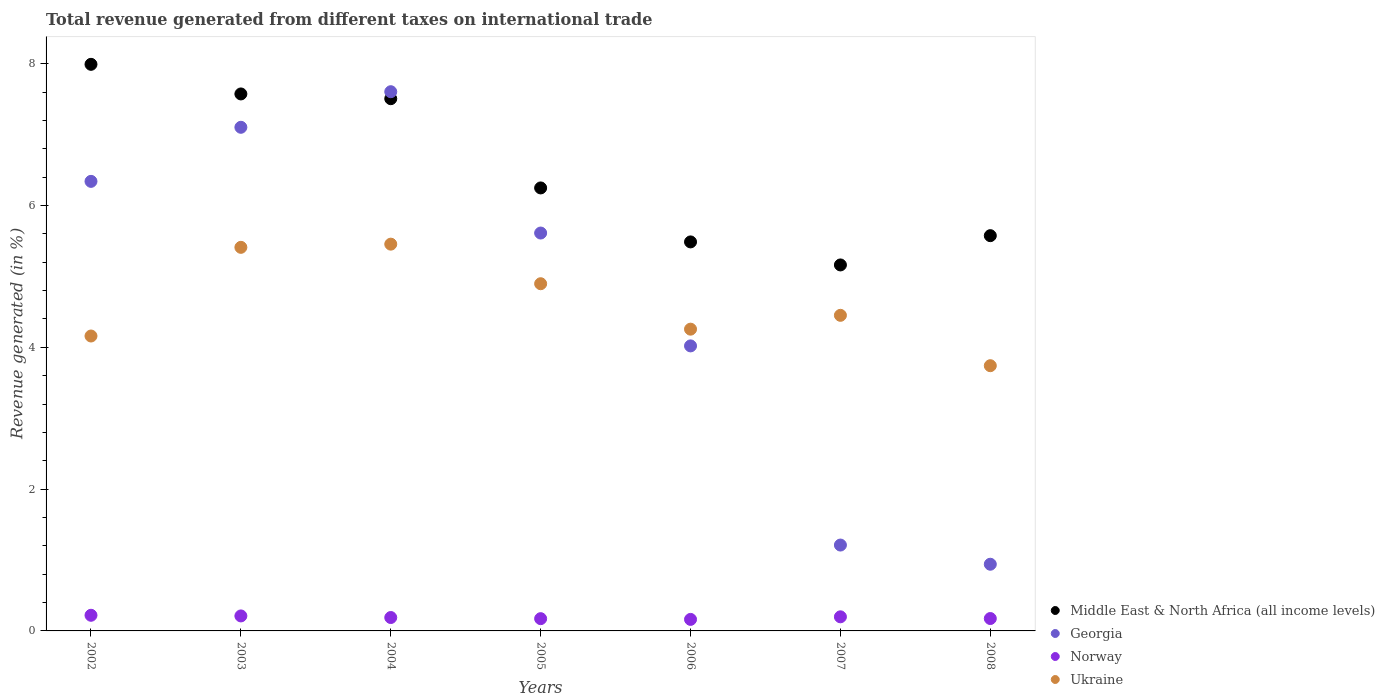Is the number of dotlines equal to the number of legend labels?
Make the answer very short. Yes. What is the total revenue generated in Georgia in 2003?
Give a very brief answer. 7.1. Across all years, what is the maximum total revenue generated in Georgia?
Ensure brevity in your answer.  7.61. Across all years, what is the minimum total revenue generated in Norway?
Keep it short and to the point. 0.16. What is the total total revenue generated in Ukraine in the graph?
Provide a short and direct response. 32.37. What is the difference between the total revenue generated in Norway in 2003 and that in 2005?
Your answer should be very brief. 0.04. What is the difference between the total revenue generated in Ukraine in 2005 and the total revenue generated in Norway in 2007?
Your answer should be very brief. 4.7. What is the average total revenue generated in Georgia per year?
Provide a succinct answer. 4.69. In the year 2005, what is the difference between the total revenue generated in Georgia and total revenue generated in Norway?
Keep it short and to the point. 5.44. What is the ratio of the total revenue generated in Norway in 2004 to that in 2006?
Your response must be concise. 1.16. Is the total revenue generated in Georgia in 2005 less than that in 2008?
Offer a terse response. No. What is the difference between the highest and the second highest total revenue generated in Middle East & North Africa (all income levels)?
Your answer should be very brief. 0.42. What is the difference between the highest and the lowest total revenue generated in Norway?
Your answer should be compact. 0.06. In how many years, is the total revenue generated in Georgia greater than the average total revenue generated in Georgia taken over all years?
Make the answer very short. 4. Is the sum of the total revenue generated in Norway in 2002 and 2005 greater than the maximum total revenue generated in Georgia across all years?
Keep it short and to the point. No. Is it the case that in every year, the sum of the total revenue generated in Middle East & North Africa (all income levels) and total revenue generated in Norway  is greater than the sum of total revenue generated in Georgia and total revenue generated in Ukraine?
Make the answer very short. Yes. Does the total revenue generated in Norway monotonically increase over the years?
Your answer should be compact. No. How many dotlines are there?
Offer a very short reply. 4. What is the difference between two consecutive major ticks on the Y-axis?
Your answer should be compact. 2. Are the values on the major ticks of Y-axis written in scientific E-notation?
Give a very brief answer. No. Does the graph contain any zero values?
Give a very brief answer. No. Does the graph contain grids?
Your answer should be compact. No. What is the title of the graph?
Make the answer very short. Total revenue generated from different taxes on international trade. Does "Lower middle income" appear as one of the legend labels in the graph?
Your answer should be very brief. No. What is the label or title of the Y-axis?
Make the answer very short. Revenue generated (in %). What is the Revenue generated (in %) of Middle East & North Africa (all income levels) in 2002?
Offer a very short reply. 7.99. What is the Revenue generated (in %) of Georgia in 2002?
Ensure brevity in your answer.  6.34. What is the Revenue generated (in %) in Norway in 2002?
Your answer should be compact. 0.22. What is the Revenue generated (in %) of Ukraine in 2002?
Ensure brevity in your answer.  4.16. What is the Revenue generated (in %) of Middle East & North Africa (all income levels) in 2003?
Your answer should be compact. 7.57. What is the Revenue generated (in %) in Georgia in 2003?
Offer a very short reply. 7.1. What is the Revenue generated (in %) of Norway in 2003?
Ensure brevity in your answer.  0.21. What is the Revenue generated (in %) in Ukraine in 2003?
Provide a short and direct response. 5.41. What is the Revenue generated (in %) of Middle East & North Africa (all income levels) in 2004?
Keep it short and to the point. 7.51. What is the Revenue generated (in %) of Georgia in 2004?
Keep it short and to the point. 7.61. What is the Revenue generated (in %) in Norway in 2004?
Your response must be concise. 0.19. What is the Revenue generated (in %) in Ukraine in 2004?
Provide a succinct answer. 5.46. What is the Revenue generated (in %) of Middle East & North Africa (all income levels) in 2005?
Give a very brief answer. 6.25. What is the Revenue generated (in %) in Georgia in 2005?
Offer a terse response. 5.61. What is the Revenue generated (in %) in Norway in 2005?
Offer a terse response. 0.17. What is the Revenue generated (in %) of Ukraine in 2005?
Offer a terse response. 4.9. What is the Revenue generated (in %) in Middle East & North Africa (all income levels) in 2006?
Ensure brevity in your answer.  5.49. What is the Revenue generated (in %) of Georgia in 2006?
Make the answer very short. 4.02. What is the Revenue generated (in %) of Norway in 2006?
Your answer should be compact. 0.16. What is the Revenue generated (in %) of Ukraine in 2006?
Provide a short and direct response. 4.26. What is the Revenue generated (in %) of Middle East & North Africa (all income levels) in 2007?
Your answer should be very brief. 5.16. What is the Revenue generated (in %) in Georgia in 2007?
Provide a succinct answer. 1.21. What is the Revenue generated (in %) of Norway in 2007?
Provide a succinct answer. 0.2. What is the Revenue generated (in %) in Ukraine in 2007?
Provide a succinct answer. 4.45. What is the Revenue generated (in %) of Middle East & North Africa (all income levels) in 2008?
Provide a short and direct response. 5.58. What is the Revenue generated (in %) of Georgia in 2008?
Your answer should be very brief. 0.94. What is the Revenue generated (in %) in Norway in 2008?
Ensure brevity in your answer.  0.17. What is the Revenue generated (in %) in Ukraine in 2008?
Offer a very short reply. 3.74. Across all years, what is the maximum Revenue generated (in %) in Middle East & North Africa (all income levels)?
Provide a short and direct response. 7.99. Across all years, what is the maximum Revenue generated (in %) of Georgia?
Offer a terse response. 7.61. Across all years, what is the maximum Revenue generated (in %) in Norway?
Make the answer very short. 0.22. Across all years, what is the maximum Revenue generated (in %) of Ukraine?
Give a very brief answer. 5.46. Across all years, what is the minimum Revenue generated (in %) of Middle East & North Africa (all income levels)?
Provide a succinct answer. 5.16. Across all years, what is the minimum Revenue generated (in %) of Georgia?
Give a very brief answer. 0.94. Across all years, what is the minimum Revenue generated (in %) in Norway?
Make the answer very short. 0.16. Across all years, what is the minimum Revenue generated (in %) of Ukraine?
Keep it short and to the point. 3.74. What is the total Revenue generated (in %) of Middle East & North Africa (all income levels) in the graph?
Your answer should be compact. 45.55. What is the total Revenue generated (in %) in Georgia in the graph?
Your answer should be very brief. 32.84. What is the total Revenue generated (in %) in Norway in the graph?
Offer a very short reply. 1.33. What is the total Revenue generated (in %) in Ukraine in the graph?
Provide a short and direct response. 32.37. What is the difference between the Revenue generated (in %) of Middle East & North Africa (all income levels) in 2002 and that in 2003?
Provide a short and direct response. 0.42. What is the difference between the Revenue generated (in %) of Georgia in 2002 and that in 2003?
Provide a short and direct response. -0.76. What is the difference between the Revenue generated (in %) in Norway in 2002 and that in 2003?
Make the answer very short. 0.01. What is the difference between the Revenue generated (in %) of Ukraine in 2002 and that in 2003?
Provide a succinct answer. -1.25. What is the difference between the Revenue generated (in %) in Middle East & North Africa (all income levels) in 2002 and that in 2004?
Your response must be concise. 0.48. What is the difference between the Revenue generated (in %) in Georgia in 2002 and that in 2004?
Make the answer very short. -1.26. What is the difference between the Revenue generated (in %) in Norway in 2002 and that in 2004?
Provide a succinct answer. 0.03. What is the difference between the Revenue generated (in %) in Ukraine in 2002 and that in 2004?
Give a very brief answer. -1.3. What is the difference between the Revenue generated (in %) in Middle East & North Africa (all income levels) in 2002 and that in 2005?
Your answer should be very brief. 1.74. What is the difference between the Revenue generated (in %) in Georgia in 2002 and that in 2005?
Keep it short and to the point. 0.73. What is the difference between the Revenue generated (in %) of Norway in 2002 and that in 2005?
Make the answer very short. 0.05. What is the difference between the Revenue generated (in %) of Ukraine in 2002 and that in 2005?
Ensure brevity in your answer.  -0.74. What is the difference between the Revenue generated (in %) of Middle East & North Africa (all income levels) in 2002 and that in 2006?
Offer a terse response. 2.5. What is the difference between the Revenue generated (in %) in Georgia in 2002 and that in 2006?
Make the answer very short. 2.32. What is the difference between the Revenue generated (in %) of Norway in 2002 and that in 2006?
Keep it short and to the point. 0.06. What is the difference between the Revenue generated (in %) in Ukraine in 2002 and that in 2006?
Give a very brief answer. -0.1. What is the difference between the Revenue generated (in %) of Middle East & North Africa (all income levels) in 2002 and that in 2007?
Your answer should be compact. 2.83. What is the difference between the Revenue generated (in %) of Georgia in 2002 and that in 2007?
Make the answer very short. 5.13. What is the difference between the Revenue generated (in %) of Norway in 2002 and that in 2007?
Your answer should be very brief. 0.02. What is the difference between the Revenue generated (in %) in Ukraine in 2002 and that in 2007?
Offer a very short reply. -0.29. What is the difference between the Revenue generated (in %) in Middle East & North Africa (all income levels) in 2002 and that in 2008?
Provide a short and direct response. 2.42. What is the difference between the Revenue generated (in %) of Georgia in 2002 and that in 2008?
Ensure brevity in your answer.  5.4. What is the difference between the Revenue generated (in %) in Norway in 2002 and that in 2008?
Provide a succinct answer. 0.05. What is the difference between the Revenue generated (in %) of Ukraine in 2002 and that in 2008?
Your answer should be compact. 0.42. What is the difference between the Revenue generated (in %) in Middle East & North Africa (all income levels) in 2003 and that in 2004?
Ensure brevity in your answer.  0.07. What is the difference between the Revenue generated (in %) of Georgia in 2003 and that in 2004?
Your response must be concise. -0.5. What is the difference between the Revenue generated (in %) of Norway in 2003 and that in 2004?
Offer a terse response. 0.02. What is the difference between the Revenue generated (in %) in Ukraine in 2003 and that in 2004?
Offer a terse response. -0.04. What is the difference between the Revenue generated (in %) in Middle East & North Africa (all income levels) in 2003 and that in 2005?
Keep it short and to the point. 1.33. What is the difference between the Revenue generated (in %) of Georgia in 2003 and that in 2005?
Provide a short and direct response. 1.49. What is the difference between the Revenue generated (in %) of Norway in 2003 and that in 2005?
Your answer should be very brief. 0.04. What is the difference between the Revenue generated (in %) of Ukraine in 2003 and that in 2005?
Offer a very short reply. 0.51. What is the difference between the Revenue generated (in %) in Middle East & North Africa (all income levels) in 2003 and that in 2006?
Make the answer very short. 2.09. What is the difference between the Revenue generated (in %) of Georgia in 2003 and that in 2006?
Offer a very short reply. 3.08. What is the difference between the Revenue generated (in %) in Norway in 2003 and that in 2006?
Offer a terse response. 0.05. What is the difference between the Revenue generated (in %) in Ukraine in 2003 and that in 2006?
Your answer should be very brief. 1.15. What is the difference between the Revenue generated (in %) in Middle East & North Africa (all income levels) in 2003 and that in 2007?
Your answer should be very brief. 2.41. What is the difference between the Revenue generated (in %) in Georgia in 2003 and that in 2007?
Give a very brief answer. 5.89. What is the difference between the Revenue generated (in %) in Norway in 2003 and that in 2007?
Offer a terse response. 0.01. What is the difference between the Revenue generated (in %) of Middle East & North Africa (all income levels) in 2003 and that in 2008?
Offer a terse response. 2. What is the difference between the Revenue generated (in %) of Georgia in 2003 and that in 2008?
Offer a very short reply. 6.16. What is the difference between the Revenue generated (in %) in Norway in 2003 and that in 2008?
Your answer should be very brief. 0.04. What is the difference between the Revenue generated (in %) in Ukraine in 2003 and that in 2008?
Offer a very short reply. 1.67. What is the difference between the Revenue generated (in %) in Middle East & North Africa (all income levels) in 2004 and that in 2005?
Your answer should be very brief. 1.26. What is the difference between the Revenue generated (in %) in Georgia in 2004 and that in 2005?
Provide a succinct answer. 1.99. What is the difference between the Revenue generated (in %) of Norway in 2004 and that in 2005?
Provide a succinct answer. 0.02. What is the difference between the Revenue generated (in %) in Ukraine in 2004 and that in 2005?
Offer a terse response. 0.56. What is the difference between the Revenue generated (in %) in Middle East & North Africa (all income levels) in 2004 and that in 2006?
Your response must be concise. 2.02. What is the difference between the Revenue generated (in %) in Georgia in 2004 and that in 2006?
Offer a very short reply. 3.59. What is the difference between the Revenue generated (in %) in Norway in 2004 and that in 2006?
Make the answer very short. 0.03. What is the difference between the Revenue generated (in %) of Ukraine in 2004 and that in 2006?
Keep it short and to the point. 1.2. What is the difference between the Revenue generated (in %) in Middle East & North Africa (all income levels) in 2004 and that in 2007?
Offer a terse response. 2.34. What is the difference between the Revenue generated (in %) of Georgia in 2004 and that in 2007?
Provide a succinct answer. 6.39. What is the difference between the Revenue generated (in %) of Norway in 2004 and that in 2007?
Make the answer very short. -0.01. What is the difference between the Revenue generated (in %) in Ukraine in 2004 and that in 2007?
Your response must be concise. 1. What is the difference between the Revenue generated (in %) in Middle East & North Africa (all income levels) in 2004 and that in 2008?
Your answer should be compact. 1.93. What is the difference between the Revenue generated (in %) of Georgia in 2004 and that in 2008?
Your answer should be compact. 6.67. What is the difference between the Revenue generated (in %) in Norway in 2004 and that in 2008?
Keep it short and to the point. 0.01. What is the difference between the Revenue generated (in %) of Ukraine in 2004 and that in 2008?
Make the answer very short. 1.71. What is the difference between the Revenue generated (in %) of Middle East & North Africa (all income levels) in 2005 and that in 2006?
Your answer should be compact. 0.76. What is the difference between the Revenue generated (in %) of Georgia in 2005 and that in 2006?
Offer a very short reply. 1.59. What is the difference between the Revenue generated (in %) in Norway in 2005 and that in 2006?
Provide a succinct answer. 0.01. What is the difference between the Revenue generated (in %) in Ukraine in 2005 and that in 2006?
Provide a short and direct response. 0.64. What is the difference between the Revenue generated (in %) of Middle East & North Africa (all income levels) in 2005 and that in 2007?
Keep it short and to the point. 1.09. What is the difference between the Revenue generated (in %) in Georgia in 2005 and that in 2007?
Your answer should be very brief. 4.4. What is the difference between the Revenue generated (in %) in Norway in 2005 and that in 2007?
Provide a short and direct response. -0.03. What is the difference between the Revenue generated (in %) of Ukraine in 2005 and that in 2007?
Offer a terse response. 0.45. What is the difference between the Revenue generated (in %) of Middle East & North Africa (all income levels) in 2005 and that in 2008?
Keep it short and to the point. 0.67. What is the difference between the Revenue generated (in %) of Georgia in 2005 and that in 2008?
Offer a terse response. 4.67. What is the difference between the Revenue generated (in %) of Norway in 2005 and that in 2008?
Ensure brevity in your answer.  -0. What is the difference between the Revenue generated (in %) of Ukraine in 2005 and that in 2008?
Offer a very short reply. 1.16. What is the difference between the Revenue generated (in %) in Middle East & North Africa (all income levels) in 2006 and that in 2007?
Make the answer very short. 0.32. What is the difference between the Revenue generated (in %) of Georgia in 2006 and that in 2007?
Your response must be concise. 2.81. What is the difference between the Revenue generated (in %) in Norway in 2006 and that in 2007?
Your answer should be very brief. -0.04. What is the difference between the Revenue generated (in %) of Ukraine in 2006 and that in 2007?
Ensure brevity in your answer.  -0.2. What is the difference between the Revenue generated (in %) of Middle East & North Africa (all income levels) in 2006 and that in 2008?
Offer a very short reply. -0.09. What is the difference between the Revenue generated (in %) in Georgia in 2006 and that in 2008?
Offer a very short reply. 3.08. What is the difference between the Revenue generated (in %) of Norway in 2006 and that in 2008?
Your response must be concise. -0.01. What is the difference between the Revenue generated (in %) of Ukraine in 2006 and that in 2008?
Provide a succinct answer. 0.52. What is the difference between the Revenue generated (in %) of Middle East & North Africa (all income levels) in 2007 and that in 2008?
Provide a succinct answer. -0.41. What is the difference between the Revenue generated (in %) of Georgia in 2007 and that in 2008?
Offer a very short reply. 0.27. What is the difference between the Revenue generated (in %) in Norway in 2007 and that in 2008?
Make the answer very short. 0.02. What is the difference between the Revenue generated (in %) in Ukraine in 2007 and that in 2008?
Give a very brief answer. 0.71. What is the difference between the Revenue generated (in %) of Middle East & North Africa (all income levels) in 2002 and the Revenue generated (in %) of Georgia in 2003?
Provide a short and direct response. 0.89. What is the difference between the Revenue generated (in %) in Middle East & North Africa (all income levels) in 2002 and the Revenue generated (in %) in Norway in 2003?
Ensure brevity in your answer.  7.78. What is the difference between the Revenue generated (in %) in Middle East & North Africa (all income levels) in 2002 and the Revenue generated (in %) in Ukraine in 2003?
Your answer should be very brief. 2.58. What is the difference between the Revenue generated (in %) of Georgia in 2002 and the Revenue generated (in %) of Norway in 2003?
Make the answer very short. 6.13. What is the difference between the Revenue generated (in %) in Georgia in 2002 and the Revenue generated (in %) in Ukraine in 2003?
Offer a terse response. 0.93. What is the difference between the Revenue generated (in %) in Norway in 2002 and the Revenue generated (in %) in Ukraine in 2003?
Make the answer very short. -5.19. What is the difference between the Revenue generated (in %) of Middle East & North Africa (all income levels) in 2002 and the Revenue generated (in %) of Georgia in 2004?
Your answer should be compact. 0.39. What is the difference between the Revenue generated (in %) of Middle East & North Africa (all income levels) in 2002 and the Revenue generated (in %) of Norway in 2004?
Give a very brief answer. 7.8. What is the difference between the Revenue generated (in %) in Middle East & North Africa (all income levels) in 2002 and the Revenue generated (in %) in Ukraine in 2004?
Provide a succinct answer. 2.54. What is the difference between the Revenue generated (in %) in Georgia in 2002 and the Revenue generated (in %) in Norway in 2004?
Make the answer very short. 6.15. What is the difference between the Revenue generated (in %) of Georgia in 2002 and the Revenue generated (in %) of Ukraine in 2004?
Offer a terse response. 0.89. What is the difference between the Revenue generated (in %) of Norway in 2002 and the Revenue generated (in %) of Ukraine in 2004?
Provide a short and direct response. -5.23. What is the difference between the Revenue generated (in %) in Middle East & North Africa (all income levels) in 2002 and the Revenue generated (in %) in Georgia in 2005?
Ensure brevity in your answer.  2.38. What is the difference between the Revenue generated (in %) of Middle East & North Africa (all income levels) in 2002 and the Revenue generated (in %) of Norway in 2005?
Ensure brevity in your answer.  7.82. What is the difference between the Revenue generated (in %) in Middle East & North Africa (all income levels) in 2002 and the Revenue generated (in %) in Ukraine in 2005?
Give a very brief answer. 3.09. What is the difference between the Revenue generated (in %) of Georgia in 2002 and the Revenue generated (in %) of Norway in 2005?
Offer a very short reply. 6.17. What is the difference between the Revenue generated (in %) of Georgia in 2002 and the Revenue generated (in %) of Ukraine in 2005?
Keep it short and to the point. 1.44. What is the difference between the Revenue generated (in %) of Norway in 2002 and the Revenue generated (in %) of Ukraine in 2005?
Make the answer very short. -4.68. What is the difference between the Revenue generated (in %) of Middle East & North Africa (all income levels) in 2002 and the Revenue generated (in %) of Georgia in 2006?
Your response must be concise. 3.97. What is the difference between the Revenue generated (in %) in Middle East & North Africa (all income levels) in 2002 and the Revenue generated (in %) in Norway in 2006?
Your answer should be compact. 7.83. What is the difference between the Revenue generated (in %) of Middle East & North Africa (all income levels) in 2002 and the Revenue generated (in %) of Ukraine in 2006?
Your answer should be compact. 3.74. What is the difference between the Revenue generated (in %) of Georgia in 2002 and the Revenue generated (in %) of Norway in 2006?
Provide a succinct answer. 6.18. What is the difference between the Revenue generated (in %) of Georgia in 2002 and the Revenue generated (in %) of Ukraine in 2006?
Your response must be concise. 2.08. What is the difference between the Revenue generated (in %) of Norway in 2002 and the Revenue generated (in %) of Ukraine in 2006?
Make the answer very short. -4.04. What is the difference between the Revenue generated (in %) of Middle East & North Africa (all income levels) in 2002 and the Revenue generated (in %) of Georgia in 2007?
Offer a terse response. 6.78. What is the difference between the Revenue generated (in %) of Middle East & North Africa (all income levels) in 2002 and the Revenue generated (in %) of Norway in 2007?
Ensure brevity in your answer.  7.79. What is the difference between the Revenue generated (in %) in Middle East & North Africa (all income levels) in 2002 and the Revenue generated (in %) in Ukraine in 2007?
Ensure brevity in your answer.  3.54. What is the difference between the Revenue generated (in %) in Georgia in 2002 and the Revenue generated (in %) in Norway in 2007?
Keep it short and to the point. 6.14. What is the difference between the Revenue generated (in %) in Georgia in 2002 and the Revenue generated (in %) in Ukraine in 2007?
Your response must be concise. 1.89. What is the difference between the Revenue generated (in %) in Norway in 2002 and the Revenue generated (in %) in Ukraine in 2007?
Provide a short and direct response. -4.23. What is the difference between the Revenue generated (in %) of Middle East & North Africa (all income levels) in 2002 and the Revenue generated (in %) of Georgia in 2008?
Offer a very short reply. 7.05. What is the difference between the Revenue generated (in %) of Middle East & North Africa (all income levels) in 2002 and the Revenue generated (in %) of Norway in 2008?
Your answer should be very brief. 7.82. What is the difference between the Revenue generated (in %) in Middle East & North Africa (all income levels) in 2002 and the Revenue generated (in %) in Ukraine in 2008?
Offer a terse response. 4.25. What is the difference between the Revenue generated (in %) of Georgia in 2002 and the Revenue generated (in %) of Norway in 2008?
Keep it short and to the point. 6.17. What is the difference between the Revenue generated (in %) in Georgia in 2002 and the Revenue generated (in %) in Ukraine in 2008?
Your answer should be very brief. 2.6. What is the difference between the Revenue generated (in %) in Norway in 2002 and the Revenue generated (in %) in Ukraine in 2008?
Give a very brief answer. -3.52. What is the difference between the Revenue generated (in %) of Middle East & North Africa (all income levels) in 2003 and the Revenue generated (in %) of Georgia in 2004?
Offer a very short reply. -0.03. What is the difference between the Revenue generated (in %) of Middle East & North Africa (all income levels) in 2003 and the Revenue generated (in %) of Norway in 2004?
Your answer should be very brief. 7.39. What is the difference between the Revenue generated (in %) in Middle East & North Africa (all income levels) in 2003 and the Revenue generated (in %) in Ukraine in 2004?
Provide a short and direct response. 2.12. What is the difference between the Revenue generated (in %) in Georgia in 2003 and the Revenue generated (in %) in Norway in 2004?
Your answer should be compact. 6.91. What is the difference between the Revenue generated (in %) of Georgia in 2003 and the Revenue generated (in %) of Ukraine in 2004?
Ensure brevity in your answer.  1.65. What is the difference between the Revenue generated (in %) of Norway in 2003 and the Revenue generated (in %) of Ukraine in 2004?
Give a very brief answer. -5.24. What is the difference between the Revenue generated (in %) in Middle East & North Africa (all income levels) in 2003 and the Revenue generated (in %) in Georgia in 2005?
Offer a very short reply. 1.96. What is the difference between the Revenue generated (in %) of Middle East & North Africa (all income levels) in 2003 and the Revenue generated (in %) of Norway in 2005?
Offer a terse response. 7.4. What is the difference between the Revenue generated (in %) of Middle East & North Africa (all income levels) in 2003 and the Revenue generated (in %) of Ukraine in 2005?
Give a very brief answer. 2.68. What is the difference between the Revenue generated (in %) in Georgia in 2003 and the Revenue generated (in %) in Norway in 2005?
Make the answer very short. 6.93. What is the difference between the Revenue generated (in %) in Georgia in 2003 and the Revenue generated (in %) in Ukraine in 2005?
Provide a succinct answer. 2.21. What is the difference between the Revenue generated (in %) in Norway in 2003 and the Revenue generated (in %) in Ukraine in 2005?
Offer a terse response. -4.69. What is the difference between the Revenue generated (in %) of Middle East & North Africa (all income levels) in 2003 and the Revenue generated (in %) of Georgia in 2006?
Make the answer very short. 3.55. What is the difference between the Revenue generated (in %) in Middle East & North Africa (all income levels) in 2003 and the Revenue generated (in %) in Norway in 2006?
Provide a succinct answer. 7.41. What is the difference between the Revenue generated (in %) in Middle East & North Africa (all income levels) in 2003 and the Revenue generated (in %) in Ukraine in 2006?
Offer a terse response. 3.32. What is the difference between the Revenue generated (in %) of Georgia in 2003 and the Revenue generated (in %) of Norway in 2006?
Your answer should be compact. 6.94. What is the difference between the Revenue generated (in %) in Georgia in 2003 and the Revenue generated (in %) in Ukraine in 2006?
Keep it short and to the point. 2.85. What is the difference between the Revenue generated (in %) in Norway in 2003 and the Revenue generated (in %) in Ukraine in 2006?
Give a very brief answer. -4.04. What is the difference between the Revenue generated (in %) of Middle East & North Africa (all income levels) in 2003 and the Revenue generated (in %) of Georgia in 2007?
Your answer should be very brief. 6.36. What is the difference between the Revenue generated (in %) in Middle East & North Africa (all income levels) in 2003 and the Revenue generated (in %) in Norway in 2007?
Ensure brevity in your answer.  7.38. What is the difference between the Revenue generated (in %) in Middle East & North Africa (all income levels) in 2003 and the Revenue generated (in %) in Ukraine in 2007?
Offer a very short reply. 3.12. What is the difference between the Revenue generated (in %) in Georgia in 2003 and the Revenue generated (in %) in Norway in 2007?
Your answer should be compact. 6.91. What is the difference between the Revenue generated (in %) in Georgia in 2003 and the Revenue generated (in %) in Ukraine in 2007?
Provide a succinct answer. 2.65. What is the difference between the Revenue generated (in %) in Norway in 2003 and the Revenue generated (in %) in Ukraine in 2007?
Ensure brevity in your answer.  -4.24. What is the difference between the Revenue generated (in %) of Middle East & North Africa (all income levels) in 2003 and the Revenue generated (in %) of Georgia in 2008?
Provide a short and direct response. 6.63. What is the difference between the Revenue generated (in %) of Middle East & North Africa (all income levels) in 2003 and the Revenue generated (in %) of Norway in 2008?
Your answer should be very brief. 7.4. What is the difference between the Revenue generated (in %) in Middle East & North Africa (all income levels) in 2003 and the Revenue generated (in %) in Ukraine in 2008?
Your answer should be compact. 3.83. What is the difference between the Revenue generated (in %) of Georgia in 2003 and the Revenue generated (in %) of Norway in 2008?
Offer a terse response. 6.93. What is the difference between the Revenue generated (in %) in Georgia in 2003 and the Revenue generated (in %) in Ukraine in 2008?
Offer a terse response. 3.36. What is the difference between the Revenue generated (in %) of Norway in 2003 and the Revenue generated (in %) of Ukraine in 2008?
Provide a succinct answer. -3.53. What is the difference between the Revenue generated (in %) of Middle East & North Africa (all income levels) in 2004 and the Revenue generated (in %) of Georgia in 2005?
Offer a very short reply. 1.89. What is the difference between the Revenue generated (in %) in Middle East & North Africa (all income levels) in 2004 and the Revenue generated (in %) in Norway in 2005?
Ensure brevity in your answer.  7.33. What is the difference between the Revenue generated (in %) in Middle East & North Africa (all income levels) in 2004 and the Revenue generated (in %) in Ukraine in 2005?
Provide a succinct answer. 2.61. What is the difference between the Revenue generated (in %) in Georgia in 2004 and the Revenue generated (in %) in Norway in 2005?
Offer a terse response. 7.43. What is the difference between the Revenue generated (in %) of Georgia in 2004 and the Revenue generated (in %) of Ukraine in 2005?
Keep it short and to the point. 2.71. What is the difference between the Revenue generated (in %) of Norway in 2004 and the Revenue generated (in %) of Ukraine in 2005?
Your answer should be compact. -4.71. What is the difference between the Revenue generated (in %) in Middle East & North Africa (all income levels) in 2004 and the Revenue generated (in %) in Georgia in 2006?
Offer a terse response. 3.49. What is the difference between the Revenue generated (in %) of Middle East & North Africa (all income levels) in 2004 and the Revenue generated (in %) of Norway in 2006?
Give a very brief answer. 7.34. What is the difference between the Revenue generated (in %) of Middle East & North Africa (all income levels) in 2004 and the Revenue generated (in %) of Ukraine in 2006?
Offer a very short reply. 3.25. What is the difference between the Revenue generated (in %) in Georgia in 2004 and the Revenue generated (in %) in Norway in 2006?
Offer a very short reply. 7.44. What is the difference between the Revenue generated (in %) in Georgia in 2004 and the Revenue generated (in %) in Ukraine in 2006?
Your response must be concise. 3.35. What is the difference between the Revenue generated (in %) in Norway in 2004 and the Revenue generated (in %) in Ukraine in 2006?
Ensure brevity in your answer.  -4.07. What is the difference between the Revenue generated (in %) of Middle East & North Africa (all income levels) in 2004 and the Revenue generated (in %) of Georgia in 2007?
Give a very brief answer. 6.3. What is the difference between the Revenue generated (in %) of Middle East & North Africa (all income levels) in 2004 and the Revenue generated (in %) of Norway in 2007?
Your answer should be compact. 7.31. What is the difference between the Revenue generated (in %) in Middle East & North Africa (all income levels) in 2004 and the Revenue generated (in %) in Ukraine in 2007?
Provide a succinct answer. 3.06. What is the difference between the Revenue generated (in %) in Georgia in 2004 and the Revenue generated (in %) in Norway in 2007?
Keep it short and to the point. 7.41. What is the difference between the Revenue generated (in %) in Georgia in 2004 and the Revenue generated (in %) in Ukraine in 2007?
Make the answer very short. 3.15. What is the difference between the Revenue generated (in %) in Norway in 2004 and the Revenue generated (in %) in Ukraine in 2007?
Your answer should be compact. -4.26. What is the difference between the Revenue generated (in %) of Middle East & North Africa (all income levels) in 2004 and the Revenue generated (in %) of Georgia in 2008?
Your response must be concise. 6.57. What is the difference between the Revenue generated (in %) in Middle East & North Africa (all income levels) in 2004 and the Revenue generated (in %) in Norway in 2008?
Your response must be concise. 7.33. What is the difference between the Revenue generated (in %) of Middle East & North Africa (all income levels) in 2004 and the Revenue generated (in %) of Ukraine in 2008?
Provide a succinct answer. 3.77. What is the difference between the Revenue generated (in %) in Georgia in 2004 and the Revenue generated (in %) in Norway in 2008?
Your answer should be very brief. 7.43. What is the difference between the Revenue generated (in %) in Georgia in 2004 and the Revenue generated (in %) in Ukraine in 2008?
Keep it short and to the point. 3.86. What is the difference between the Revenue generated (in %) of Norway in 2004 and the Revenue generated (in %) of Ukraine in 2008?
Your response must be concise. -3.55. What is the difference between the Revenue generated (in %) in Middle East & North Africa (all income levels) in 2005 and the Revenue generated (in %) in Georgia in 2006?
Your response must be concise. 2.23. What is the difference between the Revenue generated (in %) in Middle East & North Africa (all income levels) in 2005 and the Revenue generated (in %) in Norway in 2006?
Offer a terse response. 6.09. What is the difference between the Revenue generated (in %) of Middle East & North Africa (all income levels) in 2005 and the Revenue generated (in %) of Ukraine in 2006?
Make the answer very short. 1.99. What is the difference between the Revenue generated (in %) of Georgia in 2005 and the Revenue generated (in %) of Norway in 2006?
Keep it short and to the point. 5.45. What is the difference between the Revenue generated (in %) of Georgia in 2005 and the Revenue generated (in %) of Ukraine in 2006?
Provide a succinct answer. 1.36. What is the difference between the Revenue generated (in %) of Norway in 2005 and the Revenue generated (in %) of Ukraine in 2006?
Provide a short and direct response. -4.08. What is the difference between the Revenue generated (in %) of Middle East & North Africa (all income levels) in 2005 and the Revenue generated (in %) of Georgia in 2007?
Keep it short and to the point. 5.04. What is the difference between the Revenue generated (in %) of Middle East & North Africa (all income levels) in 2005 and the Revenue generated (in %) of Norway in 2007?
Ensure brevity in your answer.  6.05. What is the difference between the Revenue generated (in %) of Middle East & North Africa (all income levels) in 2005 and the Revenue generated (in %) of Ukraine in 2007?
Offer a terse response. 1.8. What is the difference between the Revenue generated (in %) of Georgia in 2005 and the Revenue generated (in %) of Norway in 2007?
Your answer should be very brief. 5.41. What is the difference between the Revenue generated (in %) in Georgia in 2005 and the Revenue generated (in %) in Ukraine in 2007?
Keep it short and to the point. 1.16. What is the difference between the Revenue generated (in %) of Norway in 2005 and the Revenue generated (in %) of Ukraine in 2007?
Provide a succinct answer. -4.28. What is the difference between the Revenue generated (in %) in Middle East & North Africa (all income levels) in 2005 and the Revenue generated (in %) in Georgia in 2008?
Your answer should be compact. 5.31. What is the difference between the Revenue generated (in %) in Middle East & North Africa (all income levels) in 2005 and the Revenue generated (in %) in Norway in 2008?
Provide a succinct answer. 6.07. What is the difference between the Revenue generated (in %) of Middle East & North Africa (all income levels) in 2005 and the Revenue generated (in %) of Ukraine in 2008?
Give a very brief answer. 2.51. What is the difference between the Revenue generated (in %) in Georgia in 2005 and the Revenue generated (in %) in Norway in 2008?
Keep it short and to the point. 5.44. What is the difference between the Revenue generated (in %) in Georgia in 2005 and the Revenue generated (in %) in Ukraine in 2008?
Ensure brevity in your answer.  1.87. What is the difference between the Revenue generated (in %) of Norway in 2005 and the Revenue generated (in %) of Ukraine in 2008?
Provide a short and direct response. -3.57. What is the difference between the Revenue generated (in %) in Middle East & North Africa (all income levels) in 2006 and the Revenue generated (in %) in Georgia in 2007?
Offer a very short reply. 4.28. What is the difference between the Revenue generated (in %) of Middle East & North Africa (all income levels) in 2006 and the Revenue generated (in %) of Norway in 2007?
Ensure brevity in your answer.  5.29. What is the difference between the Revenue generated (in %) of Middle East & North Africa (all income levels) in 2006 and the Revenue generated (in %) of Ukraine in 2007?
Make the answer very short. 1.04. What is the difference between the Revenue generated (in %) in Georgia in 2006 and the Revenue generated (in %) in Norway in 2007?
Ensure brevity in your answer.  3.82. What is the difference between the Revenue generated (in %) of Georgia in 2006 and the Revenue generated (in %) of Ukraine in 2007?
Ensure brevity in your answer.  -0.43. What is the difference between the Revenue generated (in %) of Norway in 2006 and the Revenue generated (in %) of Ukraine in 2007?
Your answer should be compact. -4.29. What is the difference between the Revenue generated (in %) of Middle East & North Africa (all income levels) in 2006 and the Revenue generated (in %) of Georgia in 2008?
Your response must be concise. 4.55. What is the difference between the Revenue generated (in %) in Middle East & North Africa (all income levels) in 2006 and the Revenue generated (in %) in Norway in 2008?
Your response must be concise. 5.31. What is the difference between the Revenue generated (in %) of Middle East & North Africa (all income levels) in 2006 and the Revenue generated (in %) of Ukraine in 2008?
Offer a terse response. 1.75. What is the difference between the Revenue generated (in %) of Georgia in 2006 and the Revenue generated (in %) of Norway in 2008?
Provide a short and direct response. 3.85. What is the difference between the Revenue generated (in %) in Georgia in 2006 and the Revenue generated (in %) in Ukraine in 2008?
Offer a terse response. 0.28. What is the difference between the Revenue generated (in %) in Norway in 2006 and the Revenue generated (in %) in Ukraine in 2008?
Your answer should be compact. -3.58. What is the difference between the Revenue generated (in %) of Middle East & North Africa (all income levels) in 2007 and the Revenue generated (in %) of Georgia in 2008?
Give a very brief answer. 4.22. What is the difference between the Revenue generated (in %) in Middle East & North Africa (all income levels) in 2007 and the Revenue generated (in %) in Norway in 2008?
Offer a very short reply. 4.99. What is the difference between the Revenue generated (in %) of Middle East & North Africa (all income levels) in 2007 and the Revenue generated (in %) of Ukraine in 2008?
Offer a very short reply. 1.42. What is the difference between the Revenue generated (in %) in Georgia in 2007 and the Revenue generated (in %) in Norway in 2008?
Give a very brief answer. 1.04. What is the difference between the Revenue generated (in %) of Georgia in 2007 and the Revenue generated (in %) of Ukraine in 2008?
Offer a very short reply. -2.53. What is the difference between the Revenue generated (in %) of Norway in 2007 and the Revenue generated (in %) of Ukraine in 2008?
Your response must be concise. -3.54. What is the average Revenue generated (in %) in Middle East & North Africa (all income levels) per year?
Offer a terse response. 6.51. What is the average Revenue generated (in %) in Georgia per year?
Give a very brief answer. 4.69. What is the average Revenue generated (in %) in Norway per year?
Ensure brevity in your answer.  0.19. What is the average Revenue generated (in %) in Ukraine per year?
Offer a terse response. 4.62. In the year 2002, what is the difference between the Revenue generated (in %) in Middle East & North Africa (all income levels) and Revenue generated (in %) in Georgia?
Offer a terse response. 1.65. In the year 2002, what is the difference between the Revenue generated (in %) of Middle East & North Africa (all income levels) and Revenue generated (in %) of Norway?
Keep it short and to the point. 7.77. In the year 2002, what is the difference between the Revenue generated (in %) in Middle East & North Africa (all income levels) and Revenue generated (in %) in Ukraine?
Your response must be concise. 3.83. In the year 2002, what is the difference between the Revenue generated (in %) in Georgia and Revenue generated (in %) in Norway?
Your answer should be very brief. 6.12. In the year 2002, what is the difference between the Revenue generated (in %) in Georgia and Revenue generated (in %) in Ukraine?
Offer a very short reply. 2.18. In the year 2002, what is the difference between the Revenue generated (in %) in Norway and Revenue generated (in %) in Ukraine?
Provide a succinct answer. -3.94. In the year 2003, what is the difference between the Revenue generated (in %) of Middle East & North Africa (all income levels) and Revenue generated (in %) of Georgia?
Provide a short and direct response. 0.47. In the year 2003, what is the difference between the Revenue generated (in %) of Middle East & North Africa (all income levels) and Revenue generated (in %) of Norway?
Your response must be concise. 7.36. In the year 2003, what is the difference between the Revenue generated (in %) of Middle East & North Africa (all income levels) and Revenue generated (in %) of Ukraine?
Provide a succinct answer. 2.16. In the year 2003, what is the difference between the Revenue generated (in %) in Georgia and Revenue generated (in %) in Norway?
Offer a very short reply. 6.89. In the year 2003, what is the difference between the Revenue generated (in %) of Georgia and Revenue generated (in %) of Ukraine?
Your response must be concise. 1.69. In the year 2003, what is the difference between the Revenue generated (in %) of Norway and Revenue generated (in %) of Ukraine?
Your answer should be very brief. -5.2. In the year 2004, what is the difference between the Revenue generated (in %) of Middle East & North Africa (all income levels) and Revenue generated (in %) of Georgia?
Keep it short and to the point. -0.1. In the year 2004, what is the difference between the Revenue generated (in %) in Middle East & North Africa (all income levels) and Revenue generated (in %) in Norway?
Keep it short and to the point. 7.32. In the year 2004, what is the difference between the Revenue generated (in %) of Middle East & North Africa (all income levels) and Revenue generated (in %) of Ukraine?
Provide a succinct answer. 2.05. In the year 2004, what is the difference between the Revenue generated (in %) in Georgia and Revenue generated (in %) in Norway?
Offer a terse response. 7.42. In the year 2004, what is the difference between the Revenue generated (in %) of Georgia and Revenue generated (in %) of Ukraine?
Offer a very short reply. 2.15. In the year 2004, what is the difference between the Revenue generated (in %) of Norway and Revenue generated (in %) of Ukraine?
Make the answer very short. -5.27. In the year 2005, what is the difference between the Revenue generated (in %) of Middle East & North Africa (all income levels) and Revenue generated (in %) of Georgia?
Give a very brief answer. 0.64. In the year 2005, what is the difference between the Revenue generated (in %) of Middle East & North Africa (all income levels) and Revenue generated (in %) of Norway?
Your answer should be compact. 6.08. In the year 2005, what is the difference between the Revenue generated (in %) of Middle East & North Africa (all income levels) and Revenue generated (in %) of Ukraine?
Your answer should be compact. 1.35. In the year 2005, what is the difference between the Revenue generated (in %) of Georgia and Revenue generated (in %) of Norway?
Your answer should be compact. 5.44. In the year 2005, what is the difference between the Revenue generated (in %) of Georgia and Revenue generated (in %) of Ukraine?
Your response must be concise. 0.71. In the year 2005, what is the difference between the Revenue generated (in %) of Norway and Revenue generated (in %) of Ukraine?
Your answer should be compact. -4.72. In the year 2006, what is the difference between the Revenue generated (in %) of Middle East & North Africa (all income levels) and Revenue generated (in %) of Georgia?
Provide a succinct answer. 1.47. In the year 2006, what is the difference between the Revenue generated (in %) of Middle East & North Africa (all income levels) and Revenue generated (in %) of Norway?
Keep it short and to the point. 5.32. In the year 2006, what is the difference between the Revenue generated (in %) in Middle East & North Africa (all income levels) and Revenue generated (in %) in Ukraine?
Ensure brevity in your answer.  1.23. In the year 2006, what is the difference between the Revenue generated (in %) of Georgia and Revenue generated (in %) of Norway?
Offer a very short reply. 3.86. In the year 2006, what is the difference between the Revenue generated (in %) of Georgia and Revenue generated (in %) of Ukraine?
Your answer should be compact. -0.24. In the year 2006, what is the difference between the Revenue generated (in %) in Norway and Revenue generated (in %) in Ukraine?
Your response must be concise. -4.09. In the year 2007, what is the difference between the Revenue generated (in %) of Middle East & North Africa (all income levels) and Revenue generated (in %) of Georgia?
Provide a succinct answer. 3.95. In the year 2007, what is the difference between the Revenue generated (in %) in Middle East & North Africa (all income levels) and Revenue generated (in %) in Norway?
Your answer should be very brief. 4.96. In the year 2007, what is the difference between the Revenue generated (in %) in Middle East & North Africa (all income levels) and Revenue generated (in %) in Ukraine?
Offer a very short reply. 0.71. In the year 2007, what is the difference between the Revenue generated (in %) in Georgia and Revenue generated (in %) in Norway?
Your answer should be very brief. 1.01. In the year 2007, what is the difference between the Revenue generated (in %) of Georgia and Revenue generated (in %) of Ukraine?
Ensure brevity in your answer.  -3.24. In the year 2007, what is the difference between the Revenue generated (in %) in Norway and Revenue generated (in %) in Ukraine?
Ensure brevity in your answer.  -4.25. In the year 2008, what is the difference between the Revenue generated (in %) of Middle East & North Africa (all income levels) and Revenue generated (in %) of Georgia?
Offer a terse response. 4.63. In the year 2008, what is the difference between the Revenue generated (in %) of Middle East & North Africa (all income levels) and Revenue generated (in %) of Norway?
Provide a succinct answer. 5.4. In the year 2008, what is the difference between the Revenue generated (in %) in Middle East & North Africa (all income levels) and Revenue generated (in %) in Ukraine?
Make the answer very short. 1.83. In the year 2008, what is the difference between the Revenue generated (in %) of Georgia and Revenue generated (in %) of Norway?
Make the answer very short. 0.77. In the year 2008, what is the difference between the Revenue generated (in %) in Georgia and Revenue generated (in %) in Ukraine?
Provide a succinct answer. -2.8. In the year 2008, what is the difference between the Revenue generated (in %) of Norway and Revenue generated (in %) of Ukraine?
Your response must be concise. -3.57. What is the ratio of the Revenue generated (in %) of Middle East & North Africa (all income levels) in 2002 to that in 2003?
Your answer should be very brief. 1.06. What is the ratio of the Revenue generated (in %) of Georgia in 2002 to that in 2003?
Offer a terse response. 0.89. What is the ratio of the Revenue generated (in %) in Norway in 2002 to that in 2003?
Your answer should be compact. 1.04. What is the ratio of the Revenue generated (in %) of Ukraine in 2002 to that in 2003?
Your response must be concise. 0.77. What is the ratio of the Revenue generated (in %) of Middle East & North Africa (all income levels) in 2002 to that in 2004?
Your response must be concise. 1.06. What is the ratio of the Revenue generated (in %) of Georgia in 2002 to that in 2004?
Your answer should be compact. 0.83. What is the ratio of the Revenue generated (in %) in Norway in 2002 to that in 2004?
Give a very brief answer. 1.17. What is the ratio of the Revenue generated (in %) in Ukraine in 2002 to that in 2004?
Ensure brevity in your answer.  0.76. What is the ratio of the Revenue generated (in %) of Middle East & North Africa (all income levels) in 2002 to that in 2005?
Your answer should be very brief. 1.28. What is the ratio of the Revenue generated (in %) in Georgia in 2002 to that in 2005?
Offer a terse response. 1.13. What is the ratio of the Revenue generated (in %) in Norway in 2002 to that in 2005?
Offer a very short reply. 1.28. What is the ratio of the Revenue generated (in %) of Ukraine in 2002 to that in 2005?
Provide a short and direct response. 0.85. What is the ratio of the Revenue generated (in %) in Middle East & North Africa (all income levels) in 2002 to that in 2006?
Offer a very short reply. 1.46. What is the ratio of the Revenue generated (in %) of Georgia in 2002 to that in 2006?
Provide a short and direct response. 1.58. What is the ratio of the Revenue generated (in %) in Norway in 2002 to that in 2006?
Offer a very short reply. 1.36. What is the ratio of the Revenue generated (in %) in Ukraine in 2002 to that in 2006?
Offer a very short reply. 0.98. What is the ratio of the Revenue generated (in %) of Middle East & North Africa (all income levels) in 2002 to that in 2007?
Provide a short and direct response. 1.55. What is the ratio of the Revenue generated (in %) of Georgia in 2002 to that in 2007?
Provide a succinct answer. 5.24. What is the ratio of the Revenue generated (in %) in Norway in 2002 to that in 2007?
Offer a terse response. 1.11. What is the ratio of the Revenue generated (in %) in Ukraine in 2002 to that in 2007?
Your response must be concise. 0.93. What is the ratio of the Revenue generated (in %) in Middle East & North Africa (all income levels) in 2002 to that in 2008?
Provide a succinct answer. 1.43. What is the ratio of the Revenue generated (in %) in Georgia in 2002 to that in 2008?
Your response must be concise. 6.74. What is the ratio of the Revenue generated (in %) in Norway in 2002 to that in 2008?
Give a very brief answer. 1.26. What is the ratio of the Revenue generated (in %) in Ukraine in 2002 to that in 2008?
Your answer should be compact. 1.11. What is the ratio of the Revenue generated (in %) of Middle East & North Africa (all income levels) in 2003 to that in 2004?
Keep it short and to the point. 1.01. What is the ratio of the Revenue generated (in %) in Georgia in 2003 to that in 2004?
Your answer should be very brief. 0.93. What is the ratio of the Revenue generated (in %) in Norway in 2003 to that in 2004?
Provide a succinct answer. 1.12. What is the ratio of the Revenue generated (in %) of Middle East & North Africa (all income levels) in 2003 to that in 2005?
Your answer should be very brief. 1.21. What is the ratio of the Revenue generated (in %) of Georgia in 2003 to that in 2005?
Keep it short and to the point. 1.27. What is the ratio of the Revenue generated (in %) in Norway in 2003 to that in 2005?
Offer a very short reply. 1.22. What is the ratio of the Revenue generated (in %) in Ukraine in 2003 to that in 2005?
Your response must be concise. 1.1. What is the ratio of the Revenue generated (in %) in Middle East & North Africa (all income levels) in 2003 to that in 2006?
Your response must be concise. 1.38. What is the ratio of the Revenue generated (in %) in Georgia in 2003 to that in 2006?
Keep it short and to the point. 1.77. What is the ratio of the Revenue generated (in %) in Ukraine in 2003 to that in 2006?
Provide a short and direct response. 1.27. What is the ratio of the Revenue generated (in %) of Middle East & North Africa (all income levels) in 2003 to that in 2007?
Your answer should be compact. 1.47. What is the ratio of the Revenue generated (in %) in Georgia in 2003 to that in 2007?
Give a very brief answer. 5.87. What is the ratio of the Revenue generated (in %) in Norway in 2003 to that in 2007?
Provide a succinct answer. 1.06. What is the ratio of the Revenue generated (in %) in Ukraine in 2003 to that in 2007?
Make the answer very short. 1.22. What is the ratio of the Revenue generated (in %) in Middle East & North Africa (all income levels) in 2003 to that in 2008?
Your response must be concise. 1.36. What is the ratio of the Revenue generated (in %) of Georgia in 2003 to that in 2008?
Your response must be concise. 7.55. What is the ratio of the Revenue generated (in %) of Norway in 2003 to that in 2008?
Provide a short and direct response. 1.21. What is the ratio of the Revenue generated (in %) in Ukraine in 2003 to that in 2008?
Make the answer very short. 1.45. What is the ratio of the Revenue generated (in %) of Middle East & North Africa (all income levels) in 2004 to that in 2005?
Make the answer very short. 1.2. What is the ratio of the Revenue generated (in %) in Georgia in 2004 to that in 2005?
Provide a short and direct response. 1.36. What is the ratio of the Revenue generated (in %) of Norway in 2004 to that in 2005?
Offer a very short reply. 1.09. What is the ratio of the Revenue generated (in %) in Ukraine in 2004 to that in 2005?
Your answer should be compact. 1.11. What is the ratio of the Revenue generated (in %) of Middle East & North Africa (all income levels) in 2004 to that in 2006?
Ensure brevity in your answer.  1.37. What is the ratio of the Revenue generated (in %) in Georgia in 2004 to that in 2006?
Your answer should be very brief. 1.89. What is the ratio of the Revenue generated (in %) of Norway in 2004 to that in 2006?
Your answer should be compact. 1.16. What is the ratio of the Revenue generated (in %) of Ukraine in 2004 to that in 2006?
Provide a succinct answer. 1.28. What is the ratio of the Revenue generated (in %) of Middle East & North Africa (all income levels) in 2004 to that in 2007?
Give a very brief answer. 1.45. What is the ratio of the Revenue generated (in %) of Georgia in 2004 to that in 2007?
Your answer should be very brief. 6.28. What is the ratio of the Revenue generated (in %) in Norway in 2004 to that in 2007?
Provide a succinct answer. 0.95. What is the ratio of the Revenue generated (in %) of Ukraine in 2004 to that in 2007?
Your response must be concise. 1.23. What is the ratio of the Revenue generated (in %) of Middle East & North Africa (all income levels) in 2004 to that in 2008?
Your response must be concise. 1.35. What is the ratio of the Revenue generated (in %) in Georgia in 2004 to that in 2008?
Give a very brief answer. 8.09. What is the ratio of the Revenue generated (in %) in Norway in 2004 to that in 2008?
Give a very brief answer. 1.08. What is the ratio of the Revenue generated (in %) in Ukraine in 2004 to that in 2008?
Provide a succinct answer. 1.46. What is the ratio of the Revenue generated (in %) of Middle East & North Africa (all income levels) in 2005 to that in 2006?
Your answer should be compact. 1.14. What is the ratio of the Revenue generated (in %) in Georgia in 2005 to that in 2006?
Give a very brief answer. 1.4. What is the ratio of the Revenue generated (in %) in Norway in 2005 to that in 2006?
Keep it short and to the point. 1.06. What is the ratio of the Revenue generated (in %) of Ukraine in 2005 to that in 2006?
Offer a very short reply. 1.15. What is the ratio of the Revenue generated (in %) in Middle East & North Africa (all income levels) in 2005 to that in 2007?
Provide a succinct answer. 1.21. What is the ratio of the Revenue generated (in %) in Georgia in 2005 to that in 2007?
Offer a very short reply. 4.63. What is the ratio of the Revenue generated (in %) of Norway in 2005 to that in 2007?
Your response must be concise. 0.87. What is the ratio of the Revenue generated (in %) of Ukraine in 2005 to that in 2007?
Offer a very short reply. 1.1. What is the ratio of the Revenue generated (in %) in Middle East & North Africa (all income levels) in 2005 to that in 2008?
Your answer should be compact. 1.12. What is the ratio of the Revenue generated (in %) of Georgia in 2005 to that in 2008?
Your response must be concise. 5.97. What is the ratio of the Revenue generated (in %) in Norway in 2005 to that in 2008?
Provide a succinct answer. 0.99. What is the ratio of the Revenue generated (in %) of Ukraine in 2005 to that in 2008?
Give a very brief answer. 1.31. What is the ratio of the Revenue generated (in %) of Middle East & North Africa (all income levels) in 2006 to that in 2007?
Your response must be concise. 1.06. What is the ratio of the Revenue generated (in %) of Georgia in 2006 to that in 2007?
Your answer should be compact. 3.32. What is the ratio of the Revenue generated (in %) in Norway in 2006 to that in 2007?
Make the answer very short. 0.82. What is the ratio of the Revenue generated (in %) in Ukraine in 2006 to that in 2007?
Ensure brevity in your answer.  0.96. What is the ratio of the Revenue generated (in %) in Middle East & North Africa (all income levels) in 2006 to that in 2008?
Your answer should be compact. 0.98. What is the ratio of the Revenue generated (in %) of Georgia in 2006 to that in 2008?
Your answer should be compact. 4.27. What is the ratio of the Revenue generated (in %) in Norway in 2006 to that in 2008?
Keep it short and to the point. 0.93. What is the ratio of the Revenue generated (in %) of Ukraine in 2006 to that in 2008?
Your answer should be compact. 1.14. What is the ratio of the Revenue generated (in %) in Middle East & North Africa (all income levels) in 2007 to that in 2008?
Your response must be concise. 0.93. What is the ratio of the Revenue generated (in %) in Georgia in 2007 to that in 2008?
Your answer should be compact. 1.29. What is the ratio of the Revenue generated (in %) in Norway in 2007 to that in 2008?
Provide a succinct answer. 1.14. What is the ratio of the Revenue generated (in %) in Ukraine in 2007 to that in 2008?
Offer a very short reply. 1.19. What is the difference between the highest and the second highest Revenue generated (in %) of Middle East & North Africa (all income levels)?
Offer a very short reply. 0.42. What is the difference between the highest and the second highest Revenue generated (in %) in Georgia?
Offer a terse response. 0.5. What is the difference between the highest and the second highest Revenue generated (in %) of Norway?
Ensure brevity in your answer.  0.01. What is the difference between the highest and the second highest Revenue generated (in %) of Ukraine?
Keep it short and to the point. 0.04. What is the difference between the highest and the lowest Revenue generated (in %) of Middle East & North Africa (all income levels)?
Give a very brief answer. 2.83. What is the difference between the highest and the lowest Revenue generated (in %) in Georgia?
Offer a very short reply. 6.67. What is the difference between the highest and the lowest Revenue generated (in %) in Norway?
Keep it short and to the point. 0.06. What is the difference between the highest and the lowest Revenue generated (in %) in Ukraine?
Offer a terse response. 1.71. 